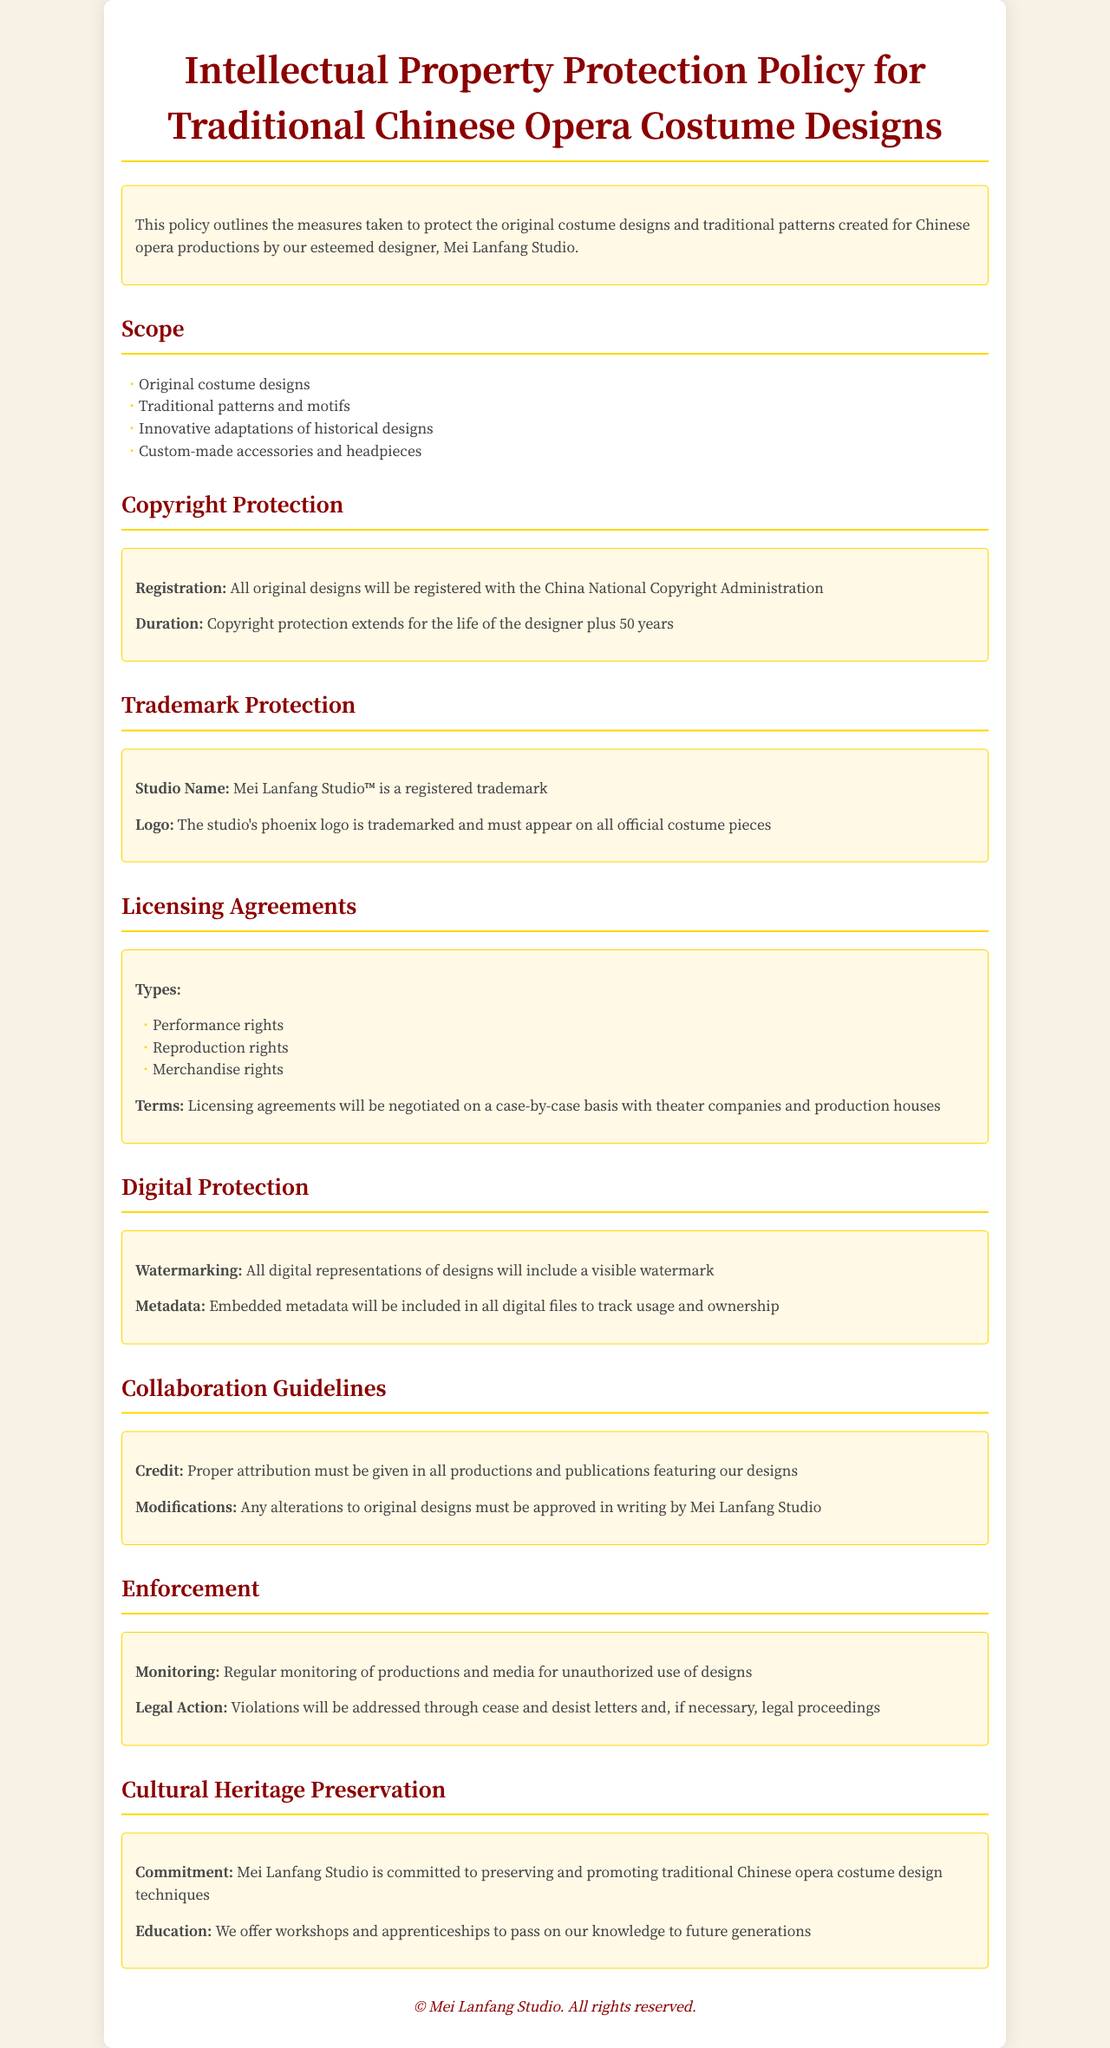What is the duration of copyright protection? The duration of copyright protection extends for the life of the designer plus 50 years.
Answer: life of the designer plus 50 years What studio name is a registered trademark? The studio name that is a registered trademark is specified in the document under Trademark Protection.
Answer: Mei Lanfang Studio™ What must appear on all official costume pieces? This requirement is mentioned in the Trademark Protection section regarding the studio's trademarked logo.
Answer: phoenix logo What types of rights are included in licensing agreements? The document lists the specific types of rights as part of the Licensing Agreements section.
Answer: Performance rights, Reproduction rights, Merchandise rights What is the purpose of watermarking? The main function of watermarking is detailed under Digital Protection in the document.
Answer: To include a visible watermark What commitment does Mei Lanfang Studio make? This commitment is outlined in the Cultural Heritage Preservation section, indicating a focus on preservation efforts.
Answer: Preserving and promoting traditional Chinese opera costume design techniques How will the studio monitor unauthorized use? The monitoring process for unauthorized use is mentioned in the Enforcement section.
Answer: Regular monitoring What must be approved in writing by Mei Lanfang Studio? This requirement relates to the guidelines regarding modifications in the Collaboration Guidelines section.
Answer: Any alterations to original designs 